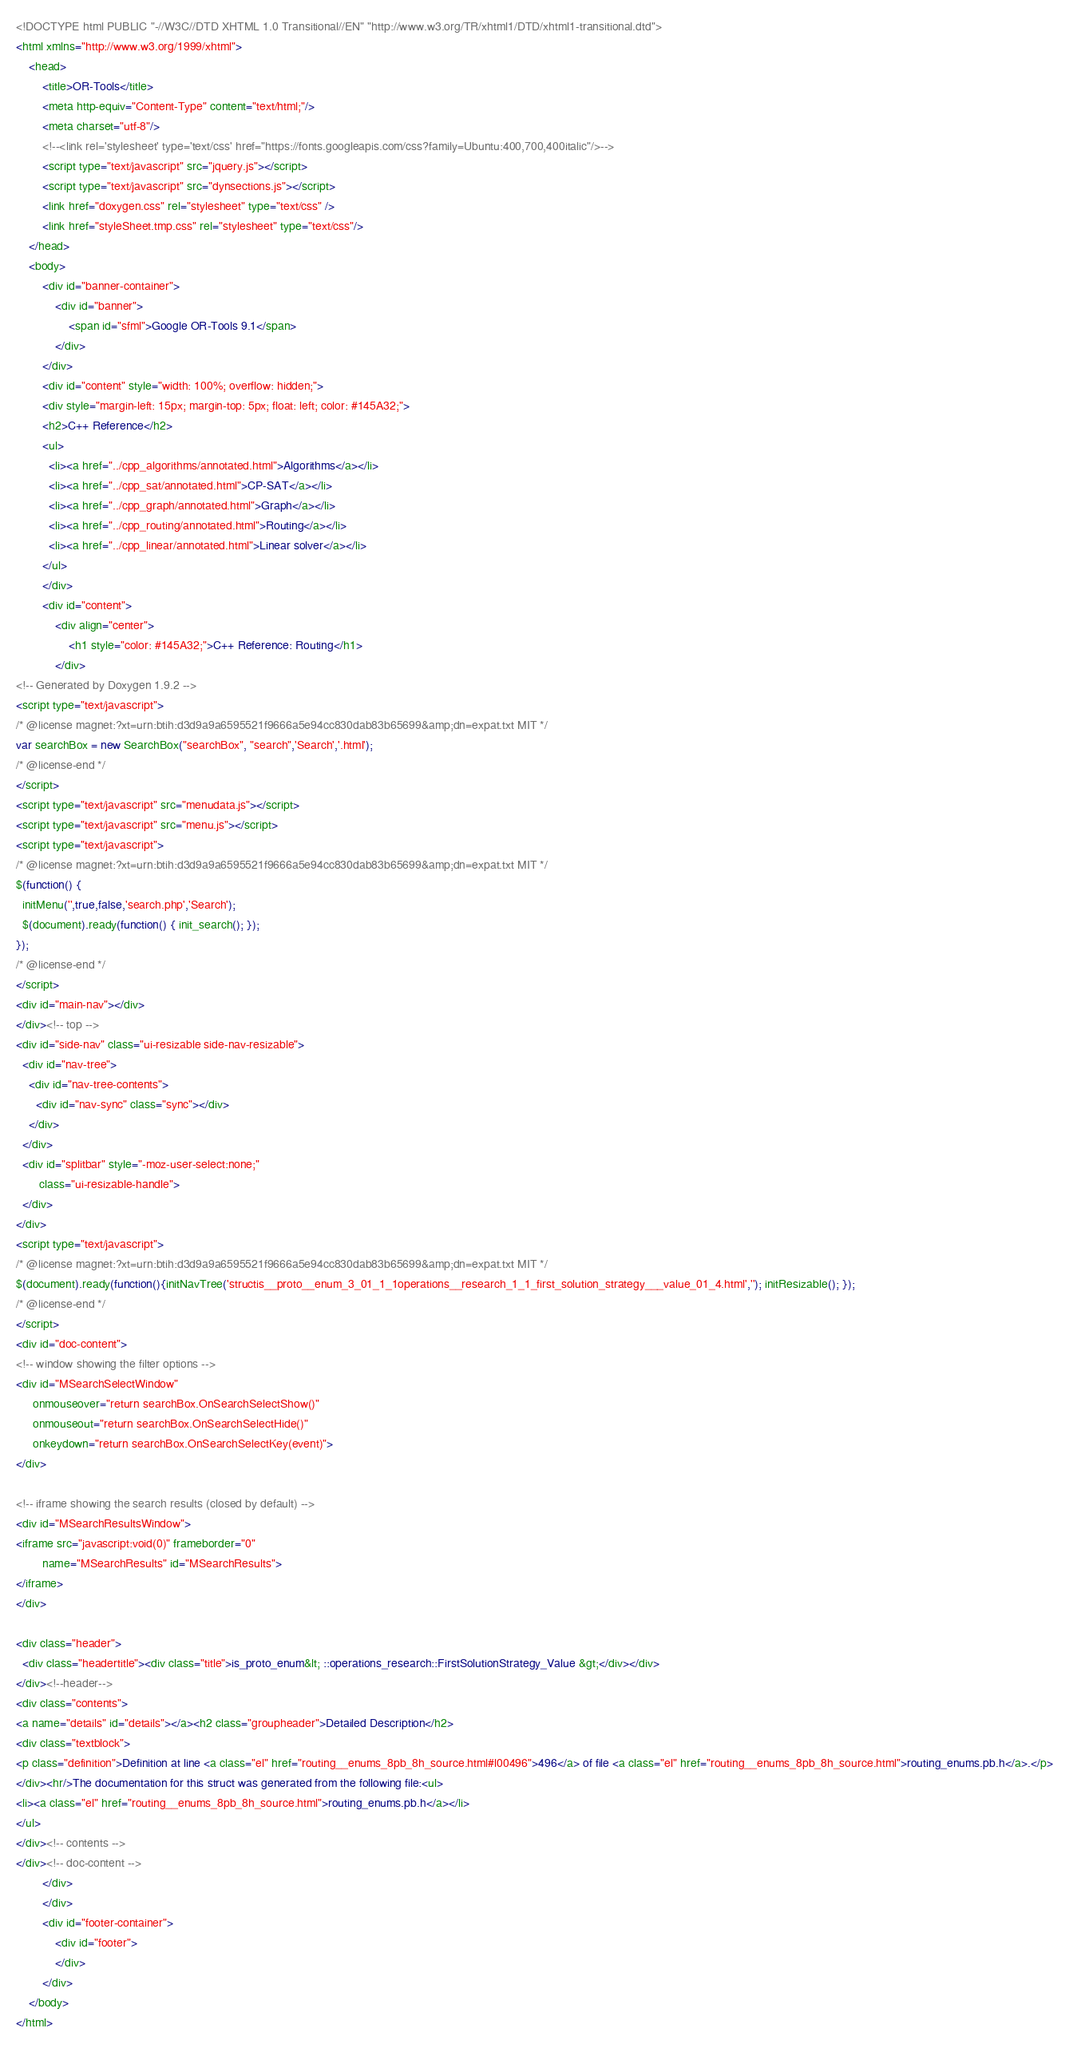<code> <loc_0><loc_0><loc_500><loc_500><_HTML_><!DOCTYPE html PUBLIC "-//W3C//DTD XHTML 1.0 Transitional//EN" "http://www.w3.org/TR/xhtml1/DTD/xhtml1-transitional.dtd">
<html xmlns="http://www.w3.org/1999/xhtml">
    <head>
        <title>OR-Tools</title>
        <meta http-equiv="Content-Type" content="text/html;"/>
        <meta charset="utf-8"/>
        <!--<link rel='stylesheet' type='text/css' href="https://fonts.googleapis.com/css?family=Ubuntu:400,700,400italic"/>-->
        <script type="text/javascript" src="jquery.js"></script>
        <script type="text/javascript" src="dynsections.js"></script>
        <link href="doxygen.css" rel="stylesheet" type="text/css" />
        <link href="styleSheet.tmp.css" rel="stylesheet" type="text/css"/>
    </head>
    <body>
        <div id="banner-container">
            <div id="banner">
                <span id="sfml">Google OR-Tools 9.1</span>
            </div>
        </div>
        <div id="content" style="width: 100%; overflow: hidden;">
        <div style="margin-left: 15px; margin-top: 5px; float: left; color: #145A32;">
        <h2>C++ Reference</h2>
        <ul>
          <li><a href="../cpp_algorithms/annotated.html">Algorithms</a></li>
          <li><a href="../cpp_sat/annotated.html">CP-SAT</a></li>
          <li><a href="../cpp_graph/annotated.html">Graph</a></li>
          <li><a href="../cpp_routing/annotated.html">Routing</a></li>
          <li><a href="../cpp_linear/annotated.html">Linear solver</a></li>
        </ul>
        </div>
        <div id="content">
            <div align="center">
                <h1 style="color: #145A32;">C++ Reference: Routing</h1>
            </div>
<!-- Generated by Doxygen 1.9.2 -->
<script type="text/javascript">
/* @license magnet:?xt=urn:btih:d3d9a9a6595521f9666a5e94cc830dab83b65699&amp;dn=expat.txt MIT */
var searchBox = new SearchBox("searchBox", "search",'Search','.html');
/* @license-end */
</script>
<script type="text/javascript" src="menudata.js"></script>
<script type="text/javascript" src="menu.js"></script>
<script type="text/javascript">
/* @license magnet:?xt=urn:btih:d3d9a9a6595521f9666a5e94cc830dab83b65699&amp;dn=expat.txt MIT */
$(function() {
  initMenu('',true,false,'search.php','Search');
  $(document).ready(function() { init_search(); });
});
/* @license-end */
</script>
<div id="main-nav"></div>
</div><!-- top -->
<div id="side-nav" class="ui-resizable side-nav-resizable">
  <div id="nav-tree">
    <div id="nav-tree-contents">
      <div id="nav-sync" class="sync"></div>
    </div>
  </div>
  <div id="splitbar" style="-moz-user-select:none;" 
       class="ui-resizable-handle">
  </div>
</div>
<script type="text/javascript">
/* @license magnet:?xt=urn:btih:d3d9a9a6595521f9666a5e94cc830dab83b65699&amp;dn=expat.txt MIT */
$(document).ready(function(){initNavTree('structis__proto__enum_3_01_1_1operations__research_1_1_first_solution_strategy___value_01_4.html',''); initResizable(); });
/* @license-end */
</script>
<div id="doc-content">
<!-- window showing the filter options -->
<div id="MSearchSelectWindow"
     onmouseover="return searchBox.OnSearchSelectShow()"
     onmouseout="return searchBox.OnSearchSelectHide()"
     onkeydown="return searchBox.OnSearchSelectKey(event)">
</div>

<!-- iframe showing the search results (closed by default) -->
<div id="MSearchResultsWindow">
<iframe src="javascript:void(0)" frameborder="0" 
        name="MSearchResults" id="MSearchResults">
</iframe>
</div>

<div class="header">
  <div class="headertitle"><div class="title">is_proto_enum&lt; ::operations_research::FirstSolutionStrategy_Value &gt;</div></div>
</div><!--header-->
<div class="contents">
<a name="details" id="details"></a><h2 class="groupheader">Detailed Description</h2>
<div class="textblock">
<p class="definition">Definition at line <a class="el" href="routing__enums_8pb_8h_source.html#l00496">496</a> of file <a class="el" href="routing__enums_8pb_8h_source.html">routing_enums.pb.h</a>.</p>
</div><hr/>The documentation for this struct was generated from the following file:<ul>
<li><a class="el" href="routing__enums_8pb_8h_source.html">routing_enums.pb.h</a></li>
</ul>
</div><!-- contents -->
</div><!-- doc-content -->
        </div>
        </div>
        <div id="footer-container">
            <div id="footer">
            </div>
        </div>
    </body>
</html>
</code> 